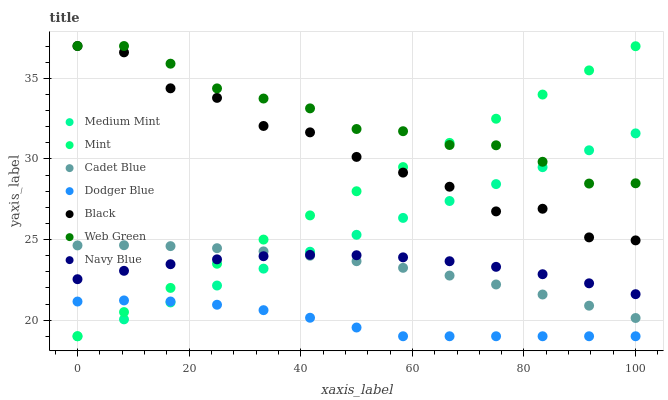Does Dodger Blue have the minimum area under the curve?
Answer yes or no. Yes. Does Web Green have the maximum area under the curve?
Answer yes or no. Yes. Does Cadet Blue have the minimum area under the curve?
Answer yes or no. No. Does Cadet Blue have the maximum area under the curve?
Answer yes or no. No. Is Medium Mint the smoothest?
Answer yes or no. Yes. Is Black the roughest?
Answer yes or no. Yes. Is Cadet Blue the smoothest?
Answer yes or no. No. Is Cadet Blue the roughest?
Answer yes or no. No. Does Medium Mint have the lowest value?
Answer yes or no. Yes. Does Cadet Blue have the lowest value?
Answer yes or no. No. Does Black have the highest value?
Answer yes or no. Yes. Does Cadet Blue have the highest value?
Answer yes or no. No. Is Dodger Blue less than Black?
Answer yes or no. Yes. Is Web Green greater than Dodger Blue?
Answer yes or no. Yes. Does Medium Mint intersect Navy Blue?
Answer yes or no. Yes. Is Medium Mint less than Navy Blue?
Answer yes or no. No. Is Medium Mint greater than Navy Blue?
Answer yes or no. No. Does Dodger Blue intersect Black?
Answer yes or no. No. 